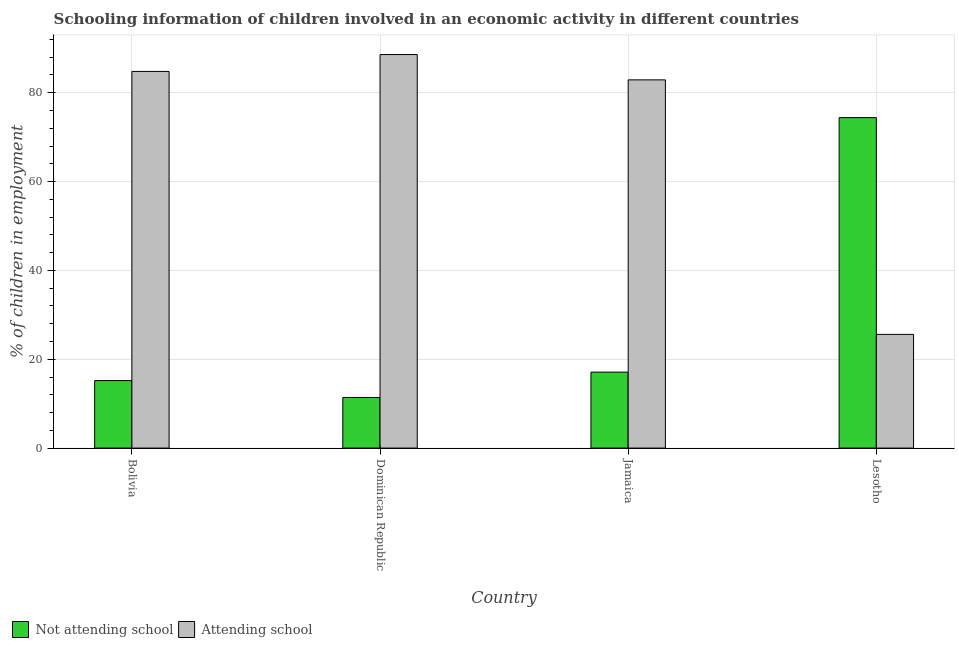How many different coloured bars are there?
Ensure brevity in your answer.  2. Are the number of bars per tick equal to the number of legend labels?
Your answer should be very brief. Yes. How many bars are there on the 4th tick from the left?
Your response must be concise. 2. How many bars are there on the 1st tick from the right?
Ensure brevity in your answer.  2. What is the label of the 4th group of bars from the left?
Keep it short and to the point. Lesotho. In how many cases, is the number of bars for a given country not equal to the number of legend labels?
Provide a succinct answer. 0. What is the percentage of employed children who are not attending school in Dominican Republic?
Offer a terse response. 11.4. Across all countries, what is the maximum percentage of employed children who are not attending school?
Provide a short and direct response. 74.4. Across all countries, what is the minimum percentage of employed children who are not attending school?
Keep it short and to the point. 11.4. In which country was the percentage of employed children who are not attending school maximum?
Provide a succinct answer. Lesotho. In which country was the percentage of employed children who are attending school minimum?
Offer a very short reply. Lesotho. What is the total percentage of employed children who are not attending school in the graph?
Keep it short and to the point. 118.1. What is the difference between the percentage of employed children who are not attending school in Bolivia and that in Lesotho?
Your answer should be very brief. -59.2. What is the difference between the percentage of employed children who are not attending school in Lesotho and the percentage of employed children who are attending school in Dominican Republic?
Your response must be concise. -14.2. What is the average percentage of employed children who are attending school per country?
Give a very brief answer. 70.47. What is the difference between the percentage of employed children who are not attending school and percentage of employed children who are attending school in Lesotho?
Your answer should be compact. 48.8. What is the ratio of the percentage of employed children who are attending school in Dominican Republic to that in Jamaica?
Provide a short and direct response. 1.07. Is the percentage of employed children who are not attending school in Bolivia less than that in Lesotho?
Your answer should be compact. Yes. What is the difference between the highest and the second highest percentage of employed children who are not attending school?
Provide a succinct answer. 57.3. What is the difference between the highest and the lowest percentage of employed children who are not attending school?
Provide a succinct answer. 63. Is the sum of the percentage of employed children who are attending school in Bolivia and Jamaica greater than the maximum percentage of employed children who are not attending school across all countries?
Your answer should be very brief. Yes. What does the 2nd bar from the left in Dominican Republic represents?
Provide a short and direct response. Attending school. What does the 2nd bar from the right in Bolivia represents?
Your answer should be very brief. Not attending school. Are all the bars in the graph horizontal?
Make the answer very short. No. Does the graph contain any zero values?
Make the answer very short. No. Does the graph contain grids?
Provide a succinct answer. Yes. Where does the legend appear in the graph?
Give a very brief answer. Bottom left. How many legend labels are there?
Provide a short and direct response. 2. How are the legend labels stacked?
Keep it short and to the point. Horizontal. What is the title of the graph?
Your answer should be very brief. Schooling information of children involved in an economic activity in different countries. Does "% of gross capital formation" appear as one of the legend labels in the graph?
Keep it short and to the point. No. What is the label or title of the Y-axis?
Offer a very short reply. % of children in employment. What is the % of children in employment of Attending school in Bolivia?
Keep it short and to the point. 84.8. What is the % of children in employment in Not attending school in Dominican Republic?
Ensure brevity in your answer.  11.4. What is the % of children in employment of Attending school in Dominican Republic?
Provide a succinct answer. 88.6. What is the % of children in employment in Attending school in Jamaica?
Provide a short and direct response. 82.9. What is the % of children in employment of Not attending school in Lesotho?
Your response must be concise. 74.4. What is the % of children in employment in Attending school in Lesotho?
Provide a short and direct response. 25.6. Across all countries, what is the maximum % of children in employment of Not attending school?
Provide a succinct answer. 74.4. Across all countries, what is the maximum % of children in employment in Attending school?
Offer a very short reply. 88.6. Across all countries, what is the minimum % of children in employment in Not attending school?
Keep it short and to the point. 11.4. Across all countries, what is the minimum % of children in employment of Attending school?
Offer a terse response. 25.6. What is the total % of children in employment of Not attending school in the graph?
Your response must be concise. 118.1. What is the total % of children in employment of Attending school in the graph?
Your answer should be compact. 281.9. What is the difference between the % of children in employment of Not attending school in Bolivia and that in Dominican Republic?
Provide a succinct answer. 3.8. What is the difference between the % of children in employment of Attending school in Bolivia and that in Dominican Republic?
Provide a short and direct response. -3.8. What is the difference between the % of children in employment in Not attending school in Bolivia and that in Jamaica?
Ensure brevity in your answer.  -1.9. What is the difference between the % of children in employment in Not attending school in Bolivia and that in Lesotho?
Keep it short and to the point. -59.2. What is the difference between the % of children in employment in Attending school in Bolivia and that in Lesotho?
Make the answer very short. 59.2. What is the difference between the % of children in employment of Not attending school in Dominican Republic and that in Jamaica?
Ensure brevity in your answer.  -5.7. What is the difference between the % of children in employment in Not attending school in Dominican Republic and that in Lesotho?
Make the answer very short. -63. What is the difference between the % of children in employment in Attending school in Dominican Republic and that in Lesotho?
Your response must be concise. 63. What is the difference between the % of children in employment in Not attending school in Jamaica and that in Lesotho?
Offer a very short reply. -57.3. What is the difference between the % of children in employment of Attending school in Jamaica and that in Lesotho?
Provide a succinct answer. 57.3. What is the difference between the % of children in employment of Not attending school in Bolivia and the % of children in employment of Attending school in Dominican Republic?
Provide a succinct answer. -73.4. What is the difference between the % of children in employment of Not attending school in Bolivia and the % of children in employment of Attending school in Jamaica?
Give a very brief answer. -67.7. What is the difference between the % of children in employment of Not attending school in Bolivia and the % of children in employment of Attending school in Lesotho?
Keep it short and to the point. -10.4. What is the difference between the % of children in employment in Not attending school in Dominican Republic and the % of children in employment in Attending school in Jamaica?
Offer a terse response. -71.5. What is the difference between the % of children in employment of Not attending school in Dominican Republic and the % of children in employment of Attending school in Lesotho?
Offer a terse response. -14.2. What is the difference between the % of children in employment in Not attending school in Jamaica and the % of children in employment in Attending school in Lesotho?
Your answer should be very brief. -8.5. What is the average % of children in employment in Not attending school per country?
Keep it short and to the point. 29.52. What is the average % of children in employment in Attending school per country?
Your answer should be very brief. 70.47. What is the difference between the % of children in employment in Not attending school and % of children in employment in Attending school in Bolivia?
Offer a very short reply. -69.6. What is the difference between the % of children in employment of Not attending school and % of children in employment of Attending school in Dominican Republic?
Provide a succinct answer. -77.2. What is the difference between the % of children in employment in Not attending school and % of children in employment in Attending school in Jamaica?
Give a very brief answer. -65.8. What is the difference between the % of children in employment of Not attending school and % of children in employment of Attending school in Lesotho?
Your answer should be compact. 48.8. What is the ratio of the % of children in employment of Attending school in Bolivia to that in Dominican Republic?
Make the answer very short. 0.96. What is the ratio of the % of children in employment in Attending school in Bolivia to that in Jamaica?
Your response must be concise. 1.02. What is the ratio of the % of children in employment in Not attending school in Bolivia to that in Lesotho?
Give a very brief answer. 0.2. What is the ratio of the % of children in employment of Attending school in Bolivia to that in Lesotho?
Your answer should be very brief. 3.31. What is the ratio of the % of children in employment in Not attending school in Dominican Republic to that in Jamaica?
Offer a terse response. 0.67. What is the ratio of the % of children in employment of Attending school in Dominican Republic to that in Jamaica?
Make the answer very short. 1.07. What is the ratio of the % of children in employment in Not attending school in Dominican Republic to that in Lesotho?
Provide a succinct answer. 0.15. What is the ratio of the % of children in employment of Attending school in Dominican Republic to that in Lesotho?
Provide a short and direct response. 3.46. What is the ratio of the % of children in employment of Not attending school in Jamaica to that in Lesotho?
Your answer should be compact. 0.23. What is the ratio of the % of children in employment of Attending school in Jamaica to that in Lesotho?
Give a very brief answer. 3.24. What is the difference between the highest and the second highest % of children in employment in Not attending school?
Make the answer very short. 57.3. 